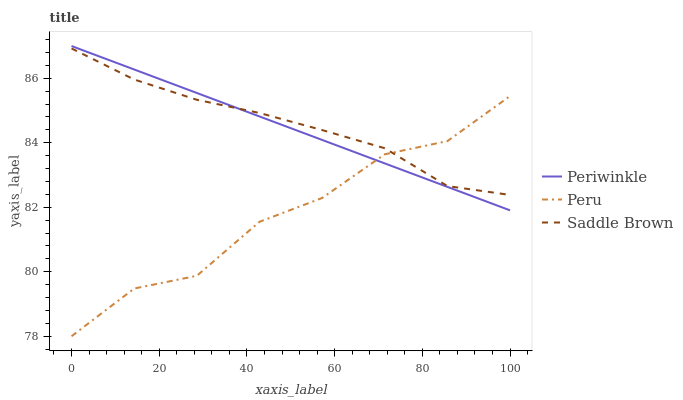Does Saddle Brown have the minimum area under the curve?
Answer yes or no. No. Does Peru have the maximum area under the curve?
Answer yes or no. No. Is Saddle Brown the smoothest?
Answer yes or no. No. Is Saddle Brown the roughest?
Answer yes or no. No. Does Saddle Brown have the lowest value?
Answer yes or no. No. Does Saddle Brown have the highest value?
Answer yes or no. No. 